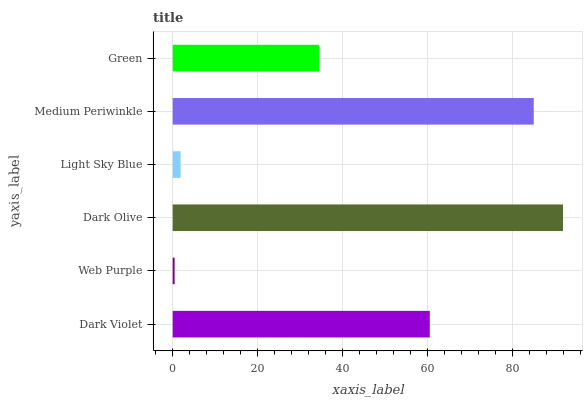Is Web Purple the minimum?
Answer yes or no. Yes. Is Dark Olive the maximum?
Answer yes or no. Yes. Is Dark Olive the minimum?
Answer yes or no. No. Is Web Purple the maximum?
Answer yes or no. No. Is Dark Olive greater than Web Purple?
Answer yes or no. Yes. Is Web Purple less than Dark Olive?
Answer yes or no. Yes. Is Web Purple greater than Dark Olive?
Answer yes or no. No. Is Dark Olive less than Web Purple?
Answer yes or no. No. Is Dark Violet the high median?
Answer yes or no. Yes. Is Green the low median?
Answer yes or no. Yes. Is Dark Olive the high median?
Answer yes or no. No. Is Dark Olive the low median?
Answer yes or no. No. 